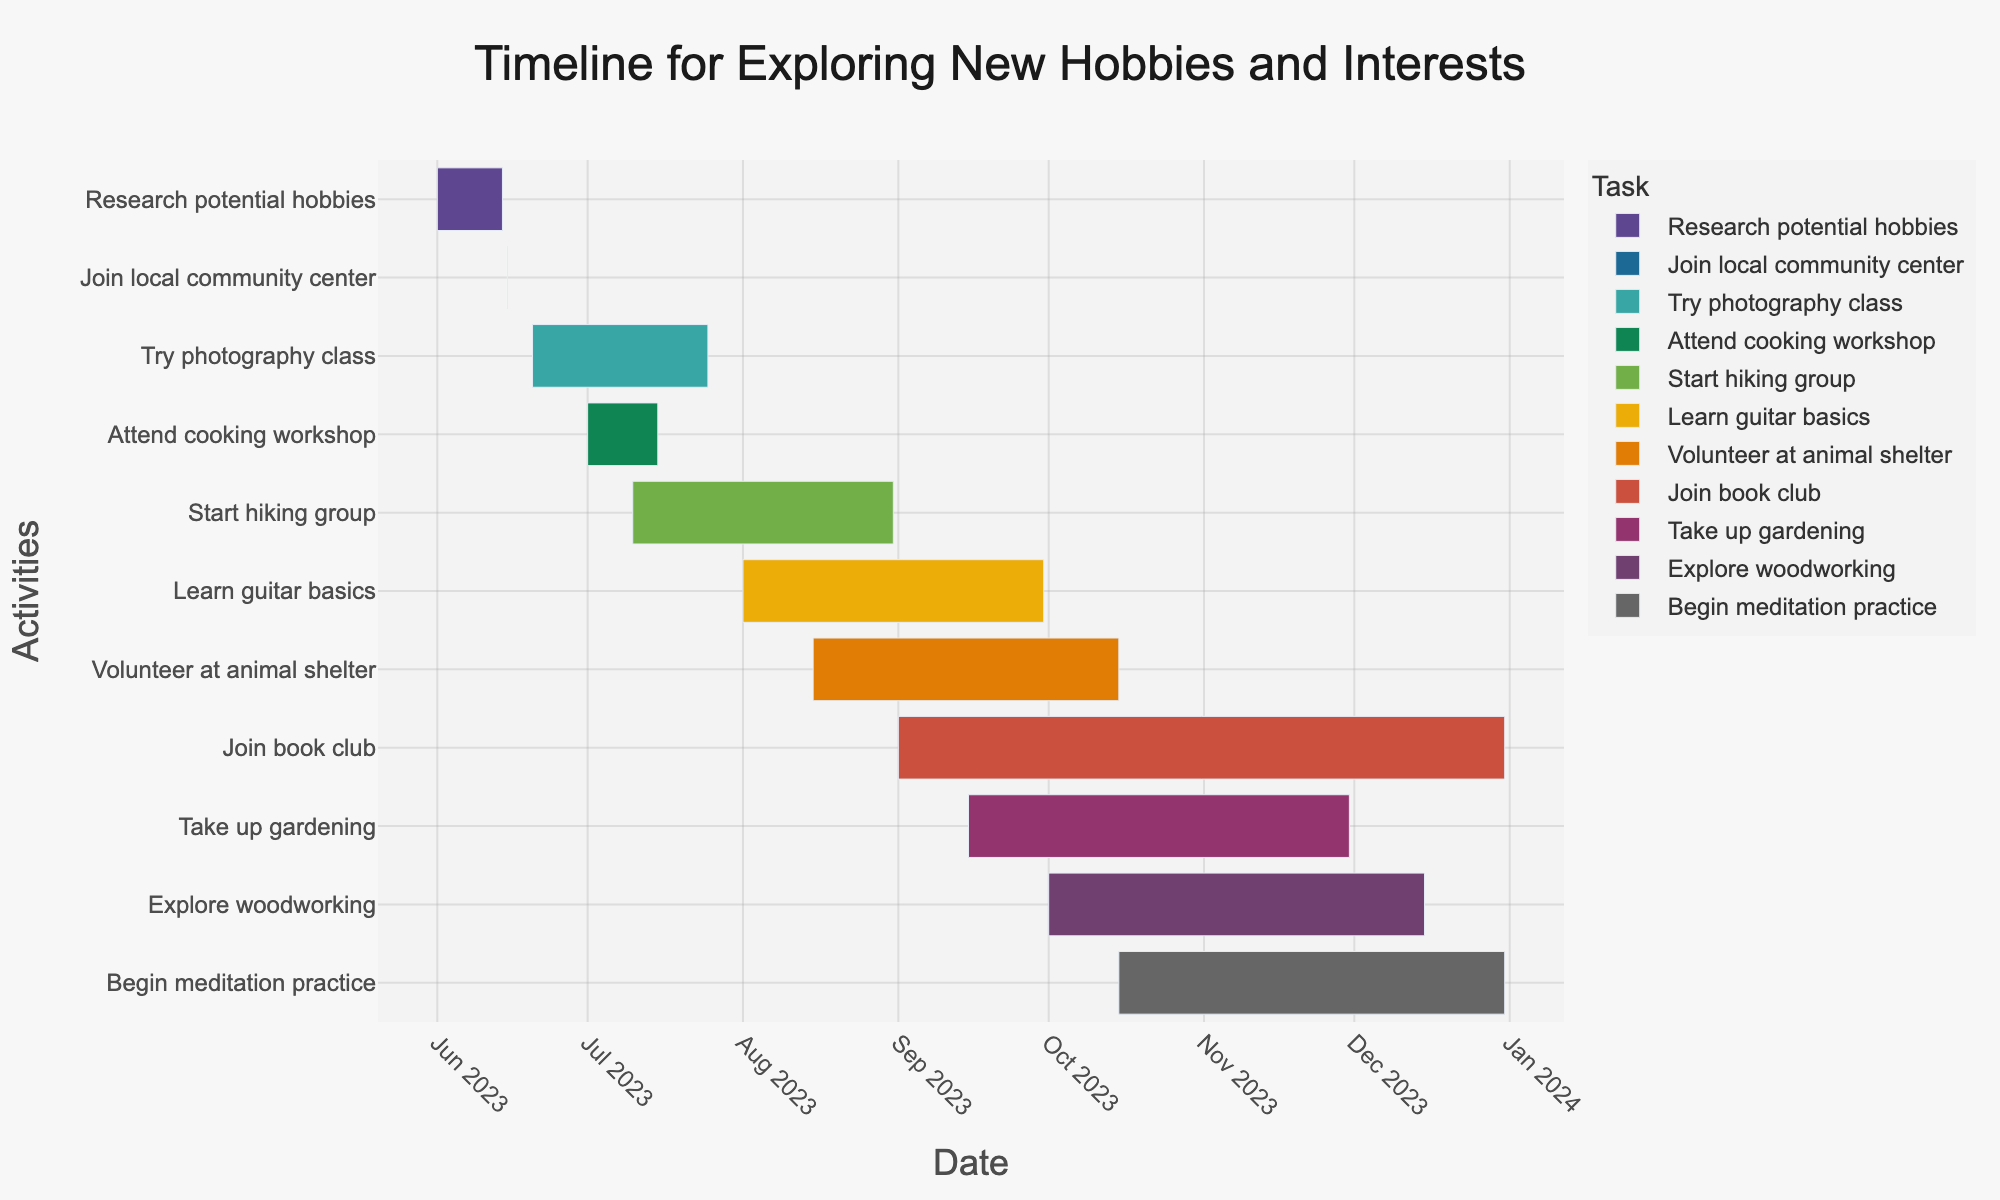What's the title of the chart? Look at the top of the chart where titles are generally placed.
Answer: Timeline for Exploring New Hobbies and Interests What dates are covered in the timeline? Check the first and last dates on the x-axis of the Gantt Chart.
Answer: June 1, 2023 to December 31, 2023 How long is the "Research potential hobbies" task? Subtract the start date from the end date (June 14, 2023 - June 1, 2023).
Answer: 14 days Which task starts the latest in the year? Find the task with the latest start date on the timeline.
Answer: Begin meditation practice How much time will be spent learning guitar basics? Subtract the start date from the end date (September 30, 2023 - August 1, 2023).
Answer: 61 days Which activities overlap in August 2023? Look for tasks that have durations spanning the month of August.
Answer: Start hiking group, Learn guitar basics, Volunteer at animal shelter What is the shortest task duration on the timeline? Identify the task with the smallest gap between start and end dates.
Answer: Join local community center How many tasks end in December 2023? Count the tasks that have their end dates in December.
Answer: 4 tasks Which task runs the longest from start to end date? Compare the durations of all tasks to find the task with the maximum duration.
Answer: Join book club Do any tasks completely overlap in both start and end dates? Check if there are any tasks with identical start and end dates.
Answer: No 